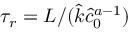<formula> <loc_0><loc_0><loc_500><loc_500>\tau _ { r } = L / ( \hat { k } \hat { c } _ { 0 } ^ { a - 1 } )</formula> 